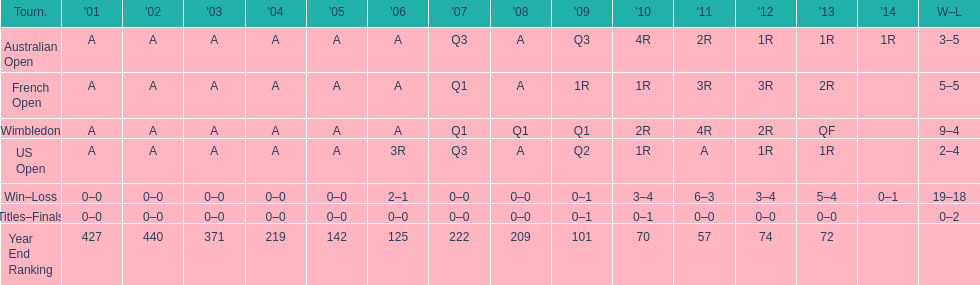In what year was the best year end ranking achieved? 2011. 